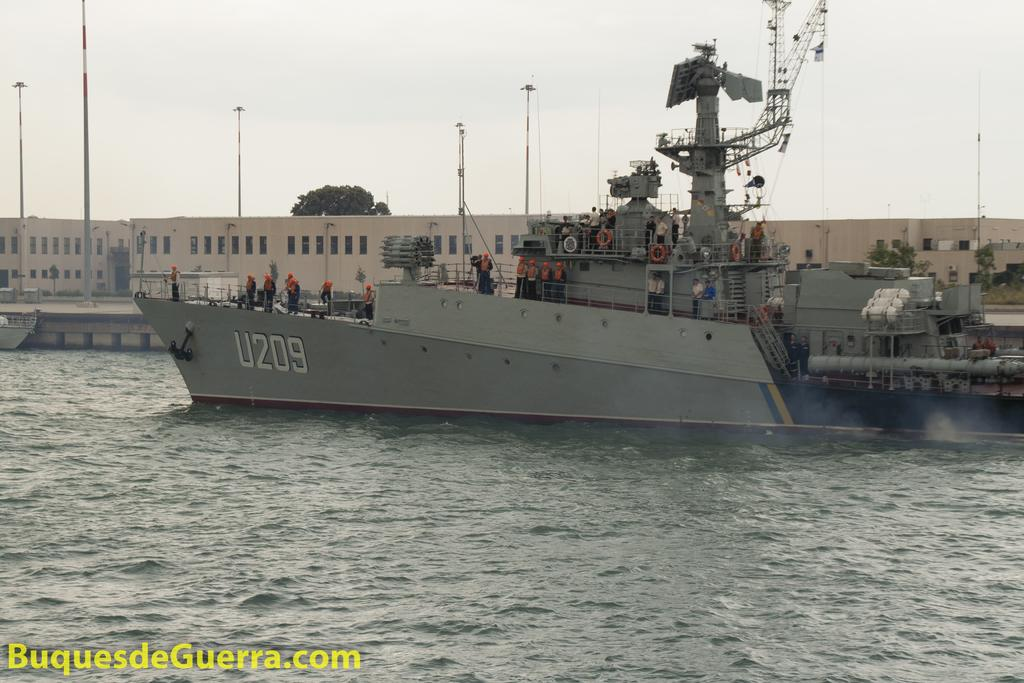What is the main subject of the image? The main subject of the image is a ship on the water. Are there any people on the ship? Yes, there are people on the ship. What can be seen in the background of the image? In the background, there are poles, trees, building structures, and the sky. Is there any text in the image? Yes, there is text at the bottom side of the image. What type of sponge is being used by the people on the ship in the image? There is no sponge visible in the image, and no indication that one is being used. What time of day is it in the image, based on the presence of the afternoon sun? The time of day cannot be determined from the image, as there is no reference to the sun or any other time-related indicators. 